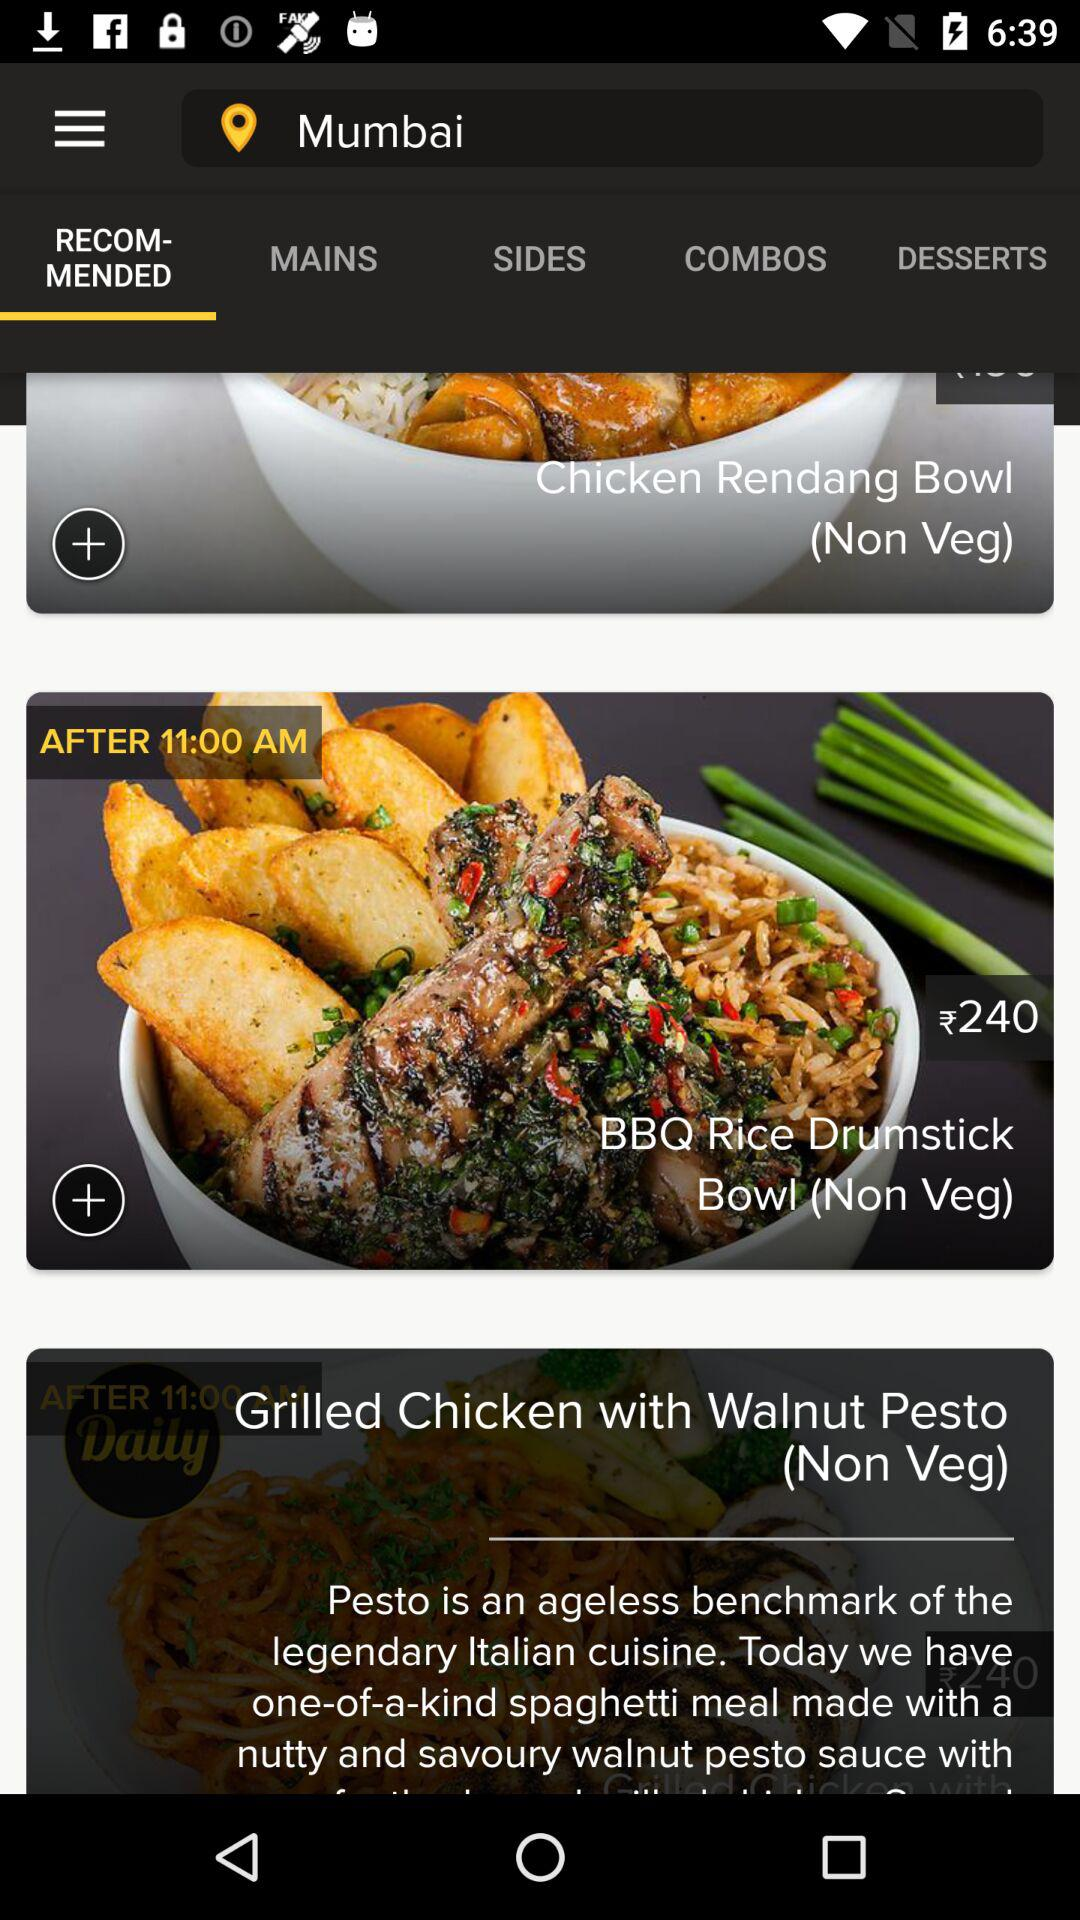What time would the "BBQ Rice Drumstick" be available? The "BBQ Rice Drumstick" will be available after 11:00 AM. 